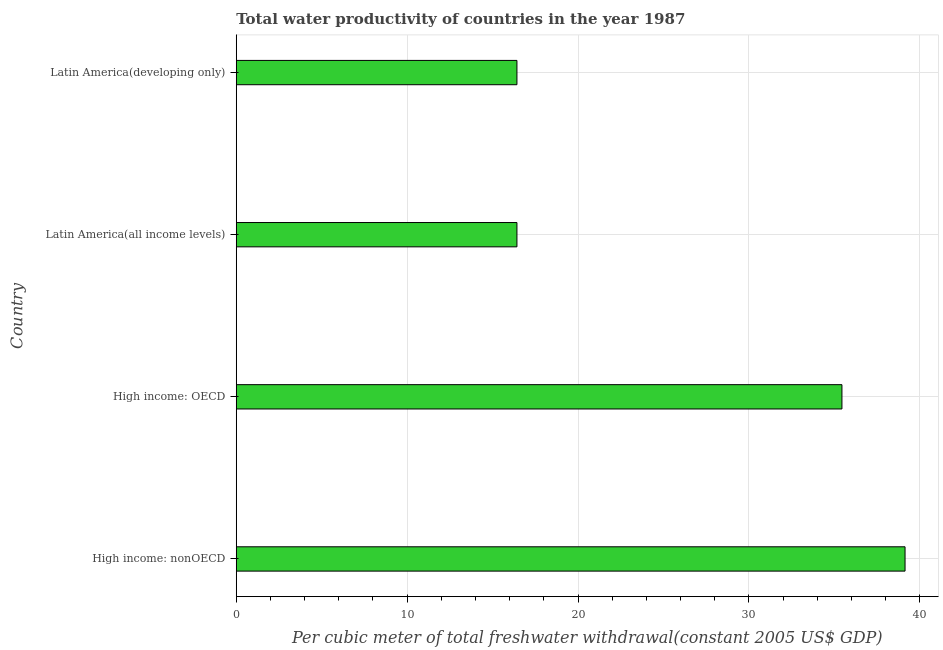Does the graph contain any zero values?
Provide a short and direct response. No. Does the graph contain grids?
Provide a succinct answer. Yes. What is the title of the graph?
Your answer should be very brief. Total water productivity of countries in the year 1987. What is the label or title of the X-axis?
Keep it short and to the point. Per cubic meter of total freshwater withdrawal(constant 2005 US$ GDP). What is the total water productivity in High income: nonOECD?
Your answer should be very brief. 39.13. Across all countries, what is the maximum total water productivity?
Your response must be concise. 39.13. Across all countries, what is the minimum total water productivity?
Keep it short and to the point. 16.42. In which country was the total water productivity maximum?
Your response must be concise. High income: nonOECD. In which country was the total water productivity minimum?
Offer a terse response. Latin America(all income levels). What is the sum of the total water productivity?
Provide a succinct answer. 107.42. What is the difference between the total water productivity in High income: OECD and Latin America(all income levels)?
Give a very brief answer. 19.02. What is the average total water productivity per country?
Your answer should be compact. 26.85. What is the median total water productivity?
Your answer should be compact. 25.93. In how many countries, is the total water productivity greater than 14 US$?
Make the answer very short. 4. What is the ratio of the total water productivity in High income: nonOECD to that in Latin America(all income levels)?
Provide a succinct answer. 2.38. Is the total water productivity in High income: nonOECD less than that in Latin America(developing only)?
Ensure brevity in your answer.  No. Is the difference between the total water productivity in High income: OECD and Latin America(developing only) greater than the difference between any two countries?
Your response must be concise. No. What is the difference between the highest and the second highest total water productivity?
Your answer should be compact. 3.69. Is the sum of the total water productivity in Latin America(all income levels) and Latin America(developing only) greater than the maximum total water productivity across all countries?
Provide a short and direct response. No. What is the difference between the highest and the lowest total water productivity?
Your answer should be compact. 22.71. In how many countries, is the total water productivity greater than the average total water productivity taken over all countries?
Your answer should be compact. 2. How many bars are there?
Offer a very short reply. 4. Are all the bars in the graph horizontal?
Your answer should be very brief. Yes. How many countries are there in the graph?
Make the answer very short. 4. What is the Per cubic meter of total freshwater withdrawal(constant 2005 US$ GDP) of High income: nonOECD?
Your answer should be compact. 39.13. What is the Per cubic meter of total freshwater withdrawal(constant 2005 US$ GDP) of High income: OECD?
Your answer should be very brief. 35.44. What is the Per cubic meter of total freshwater withdrawal(constant 2005 US$ GDP) of Latin America(all income levels)?
Your answer should be compact. 16.42. What is the Per cubic meter of total freshwater withdrawal(constant 2005 US$ GDP) of Latin America(developing only)?
Offer a terse response. 16.42. What is the difference between the Per cubic meter of total freshwater withdrawal(constant 2005 US$ GDP) in High income: nonOECD and High income: OECD?
Make the answer very short. 3.69. What is the difference between the Per cubic meter of total freshwater withdrawal(constant 2005 US$ GDP) in High income: nonOECD and Latin America(all income levels)?
Ensure brevity in your answer.  22.71. What is the difference between the Per cubic meter of total freshwater withdrawal(constant 2005 US$ GDP) in High income: nonOECD and Latin America(developing only)?
Give a very brief answer. 22.71. What is the difference between the Per cubic meter of total freshwater withdrawal(constant 2005 US$ GDP) in High income: OECD and Latin America(all income levels)?
Keep it short and to the point. 19.02. What is the difference between the Per cubic meter of total freshwater withdrawal(constant 2005 US$ GDP) in High income: OECD and Latin America(developing only)?
Offer a very short reply. 19.02. What is the difference between the Per cubic meter of total freshwater withdrawal(constant 2005 US$ GDP) in Latin America(all income levels) and Latin America(developing only)?
Your response must be concise. 0. What is the ratio of the Per cubic meter of total freshwater withdrawal(constant 2005 US$ GDP) in High income: nonOECD to that in High income: OECD?
Give a very brief answer. 1.1. What is the ratio of the Per cubic meter of total freshwater withdrawal(constant 2005 US$ GDP) in High income: nonOECD to that in Latin America(all income levels)?
Keep it short and to the point. 2.38. What is the ratio of the Per cubic meter of total freshwater withdrawal(constant 2005 US$ GDP) in High income: nonOECD to that in Latin America(developing only)?
Make the answer very short. 2.38. What is the ratio of the Per cubic meter of total freshwater withdrawal(constant 2005 US$ GDP) in High income: OECD to that in Latin America(all income levels)?
Ensure brevity in your answer.  2.16. What is the ratio of the Per cubic meter of total freshwater withdrawal(constant 2005 US$ GDP) in High income: OECD to that in Latin America(developing only)?
Provide a short and direct response. 2.16. 